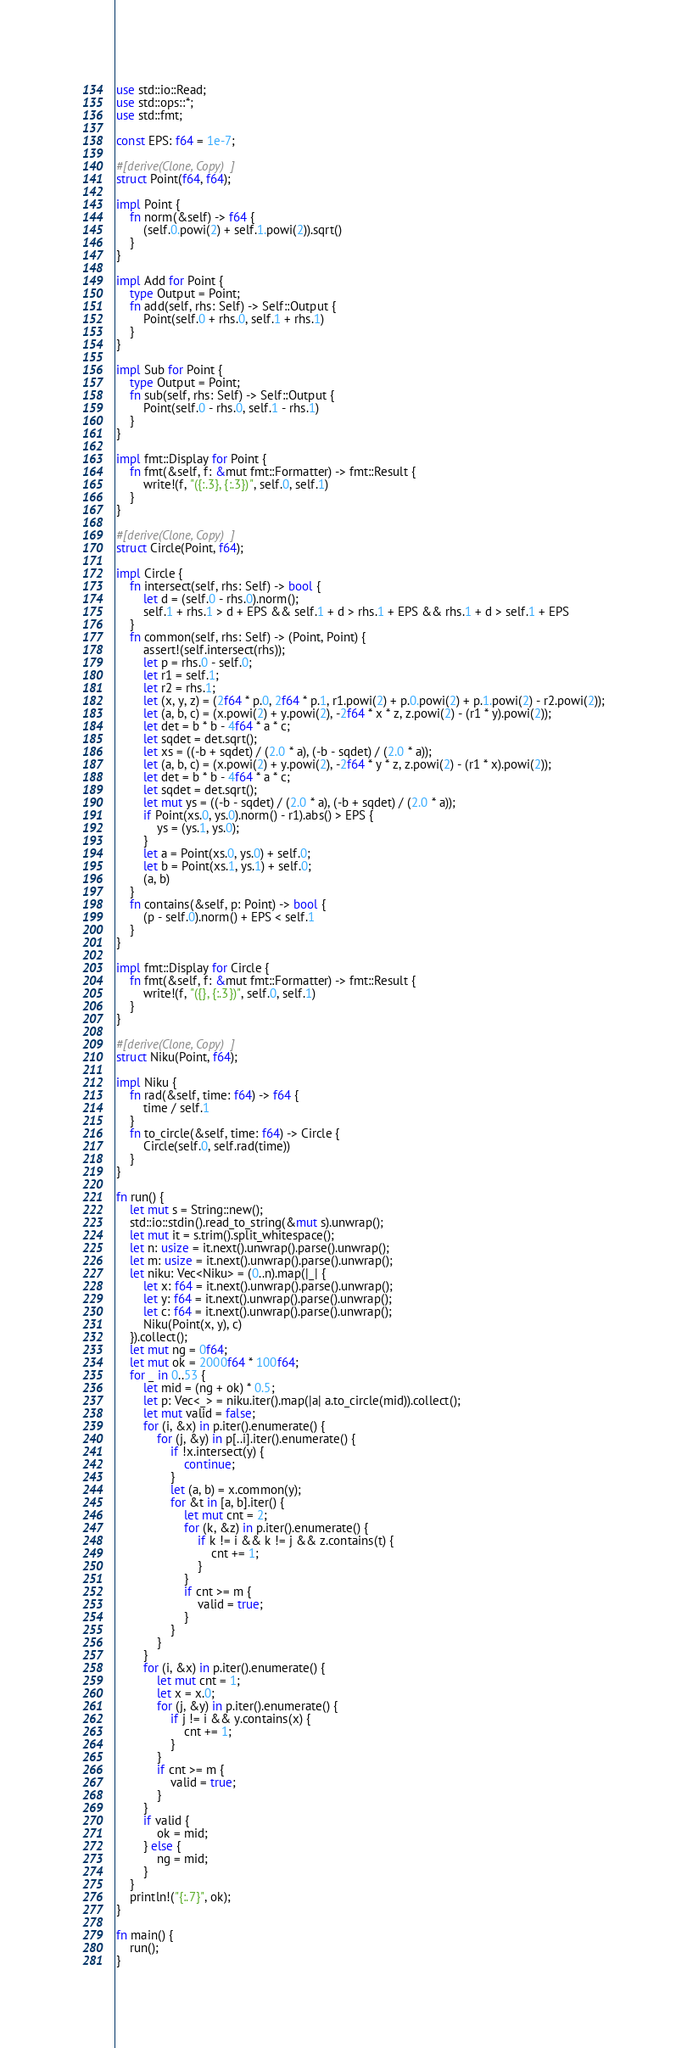Convert code to text. <code><loc_0><loc_0><loc_500><loc_500><_Rust_>use std::io::Read;
use std::ops::*;
use std::fmt;

const EPS: f64 = 1e-7;

#[derive(Clone, Copy)]
struct Point(f64, f64);

impl Point {
    fn norm(&self) -> f64 {
        (self.0.powi(2) + self.1.powi(2)).sqrt()
    }
}

impl Add for Point {
    type Output = Point;
    fn add(self, rhs: Self) -> Self::Output {
        Point(self.0 + rhs.0, self.1 + rhs.1)
    }
}

impl Sub for Point {
    type Output = Point;
    fn sub(self, rhs: Self) -> Self::Output {
        Point(self.0 - rhs.0, self.1 - rhs.1)
    }
}

impl fmt::Display for Point {
    fn fmt(&self, f: &mut fmt::Formatter) -> fmt::Result {
        write!(f, "({:.3}, {:.3})", self.0, self.1)
    }
}

#[derive(Clone, Copy)]
struct Circle(Point, f64);

impl Circle {
    fn intersect(self, rhs: Self) -> bool {
        let d = (self.0 - rhs.0).norm();
        self.1 + rhs.1 > d + EPS && self.1 + d > rhs.1 + EPS && rhs.1 + d > self.1 + EPS
    }
    fn common(self, rhs: Self) -> (Point, Point) {
        assert!(self.intersect(rhs));
        let p = rhs.0 - self.0;
        let r1 = self.1;
        let r2 = rhs.1;
        let (x, y, z) = (2f64 * p.0, 2f64 * p.1, r1.powi(2) + p.0.powi(2) + p.1.powi(2) - r2.powi(2));
        let (a, b, c) = (x.powi(2) + y.powi(2), -2f64 * x * z, z.powi(2) - (r1 * y).powi(2));
        let det = b * b - 4f64 * a * c;
        let sqdet = det.sqrt();
        let xs = ((-b + sqdet) / (2.0 * a), (-b - sqdet) / (2.0 * a));
        let (a, b, c) = (x.powi(2) + y.powi(2), -2f64 * y * z, z.powi(2) - (r1 * x).powi(2));
        let det = b * b - 4f64 * a * c;
        let sqdet = det.sqrt();
        let mut ys = ((-b - sqdet) / (2.0 * a), (-b + sqdet) / (2.0 * a));
        if Point(xs.0, ys.0).norm() - r1).abs() > EPS {
            ys = (ys.1, ys.0);
        }
        let a = Point(xs.0, ys.0) + self.0;
        let b = Point(xs.1, ys.1) + self.0;
        (a, b)
    }
    fn contains(&self, p: Point) -> bool {
        (p - self.0).norm() + EPS < self.1
    }
}

impl fmt::Display for Circle {
    fn fmt(&self, f: &mut fmt::Formatter) -> fmt::Result {
        write!(f, "({}, {:.3})", self.0, self.1)
    }
}

#[derive(Clone, Copy)]
struct Niku(Point, f64);

impl Niku {
    fn rad(&self, time: f64) -> f64 {
        time / self.1
    }
    fn to_circle(&self, time: f64) -> Circle {
        Circle(self.0, self.rad(time))
    }
}

fn run() {
    let mut s = String::new();
    std::io::stdin().read_to_string(&mut s).unwrap();
    let mut it = s.trim().split_whitespace();
    let n: usize = it.next().unwrap().parse().unwrap();
    let m: usize = it.next().unwrap().parse().unwrap();
    let niku: Vec<Niku> = (0..n).map(|_| {
        let x: f64 = it.next().unwrap().parse().unwrap();
        let y: f64 = it.next().unwrap().parse().unwrap();
        let c: f64 = it.next().unwrap().parse().unwrap();
        Niku(Point(x, y), c)
    }).collect();
    let mut ng = 0f64;
    let mut ok = 2000f64 * 100f64;
    for _ in 0..53 {
        let mid = (ng + ok) * 0.5;
        let p: Vec<_> = niku.iter().map(|a| a.to_circle(mid)).collect();
        let mut valid = false;
        for (i, &x) in p.iter().enumerate() {
            for (j, &y) in p[..i].iter().enumerate() {
                if !x.intersect(y) {
                    continue;
                }
                let (a, b) = x.common(y);
                for &t in [a, b].iter() {
                    let mut cnt = 2;
                    for (k, &z) in p.iter().enumerate() {
                        if k != i && k != j && z.contains(t) {
                            cnt += 1;
                        }
                    }
                    if cnt >= m {
                        valid = true;
                    }
                }
            }
        }
        for (i, &x) in p.iter().enumerate() {
            let mut cnt = 1;
            let x = x.0;
            for (j, &y) in p.iter().enumerate() {
                if j != i && y.contains(x) {
                    cnt += 1;
                }
            }
            if cnt >= m {
                valid = true;
            }
        }
        if valid {
            ok = mid;
        } else {
            ng = mid;
        }
    }
    println!("{:.7}", ok);
}

fn main() {
    run();
}
</code> 